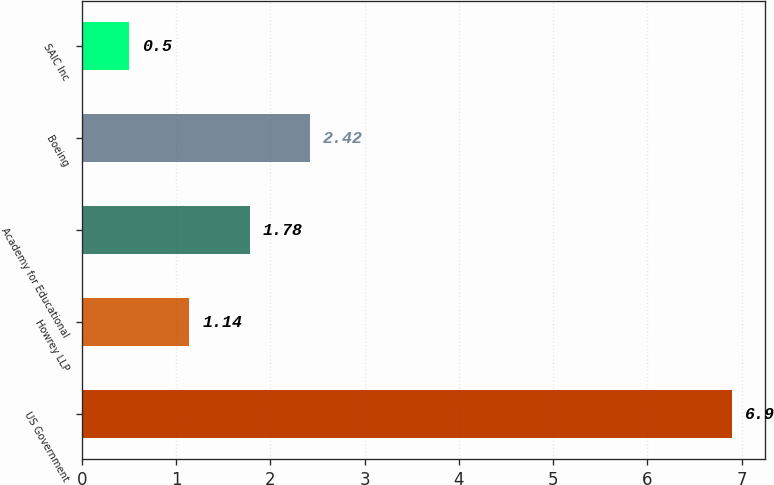<chart> <loc_0><loc_0><loc_500><loc_500><bar_chart><fcel>US Government<fcel>Howrey LLP<fcel>Academy for Educational<fcel>Boeing<fcel>SAIC Inc<nl><fcel>6.9<fcel>1.14<fcel>1.78<fcel>2.42<fcel>0.5<nl></chart> 